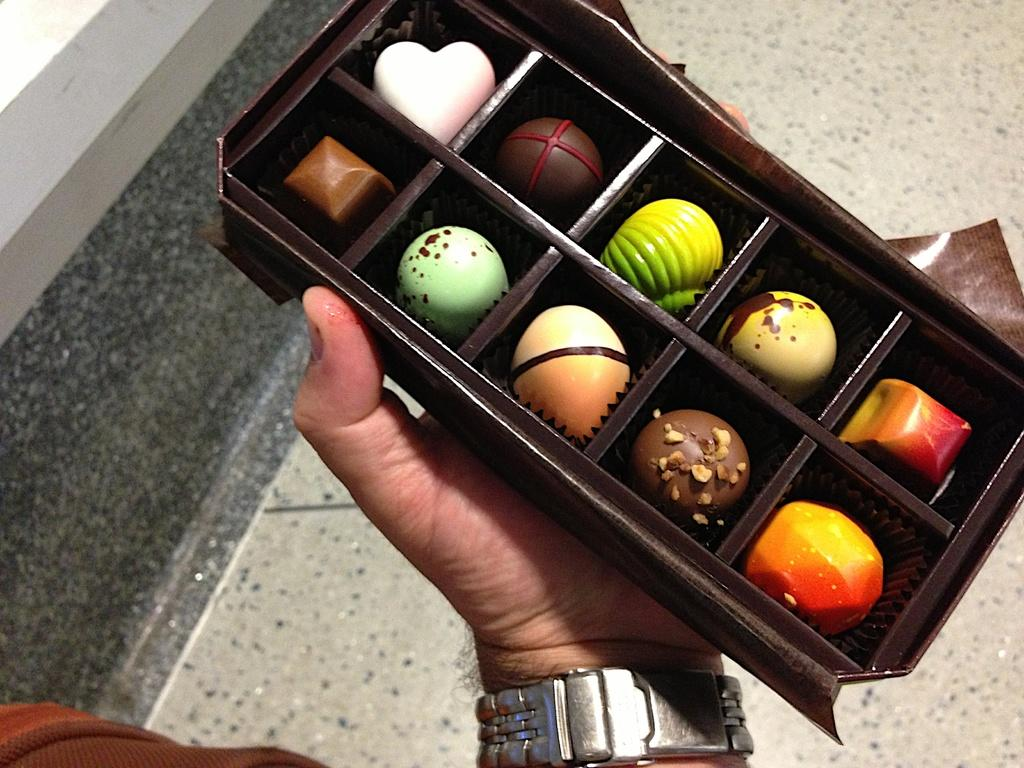What type of candy is shown in the image? There are round chocolates in the image. How are the chocolates arranged or contained? The chocolates are in a brown tray. Who is holding the tray of chocolates? A person is holding the tray. What type of flooring can be seen in the background of the image? There is flooring tile visible in the background of the image. What month is it in the image? The image does not provide any information about the month or time of year. 